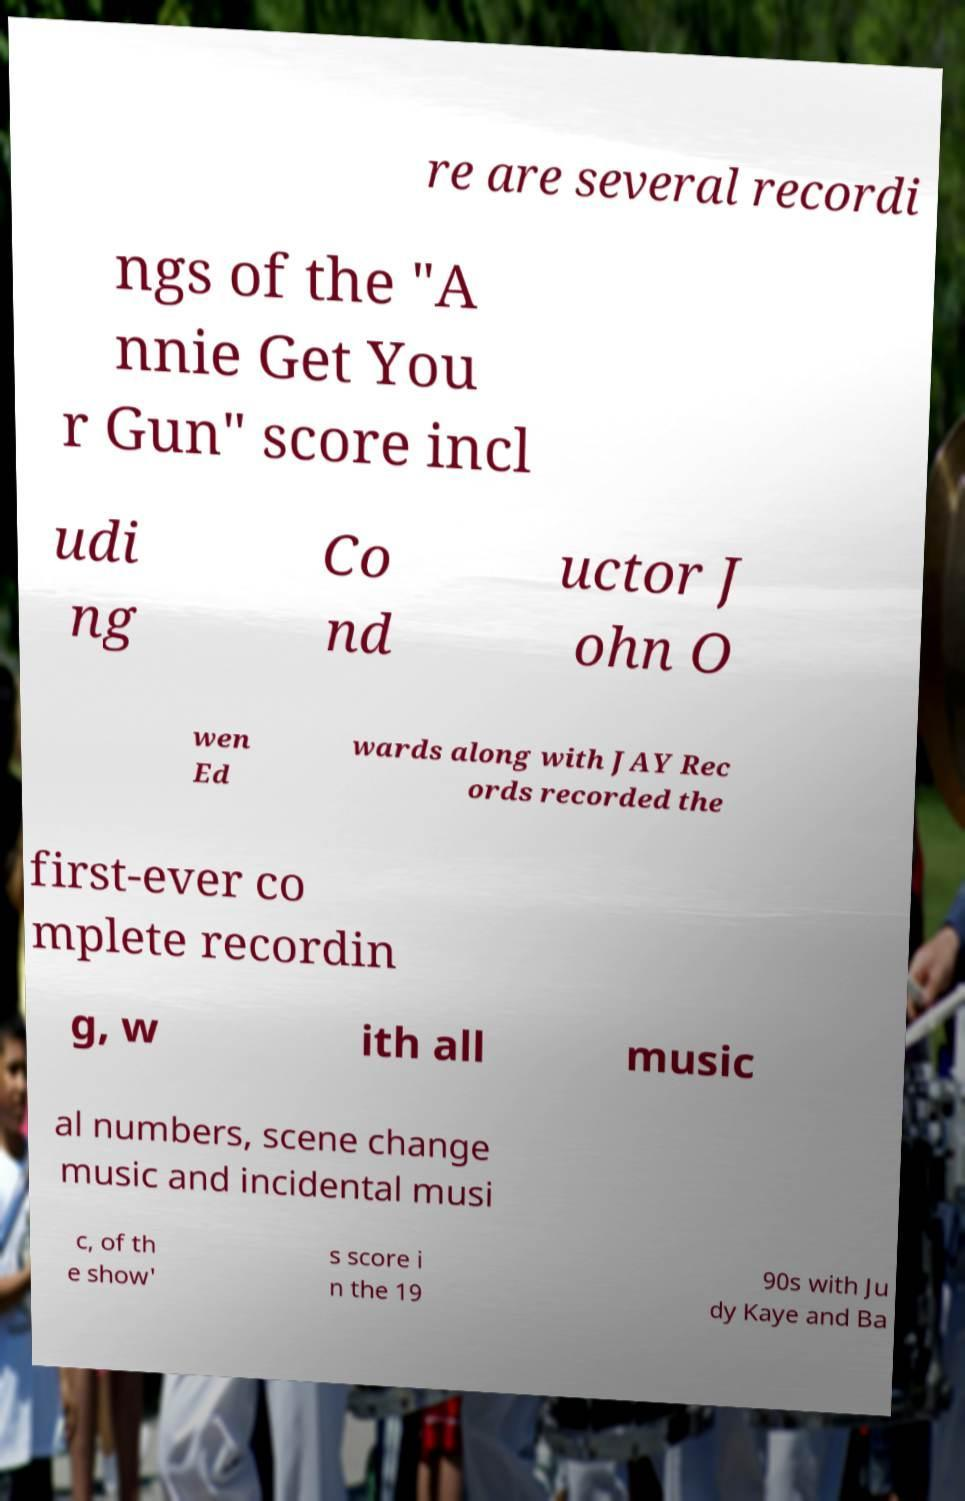Could you assist in decoding the text presented in this image and type it out clearly? re are several recordi ngs of the "A nnie Get You r Gun" score incl udi ng Co nd uctor J ohn O wen Ed wards along with JAY Rec ords recorded the first-ever co mplete recordin g, w ith all music al numbers, scene change music and incidental musi c, of th e show' s score i n the 19 90s with Ju dy Kaye and Ba 